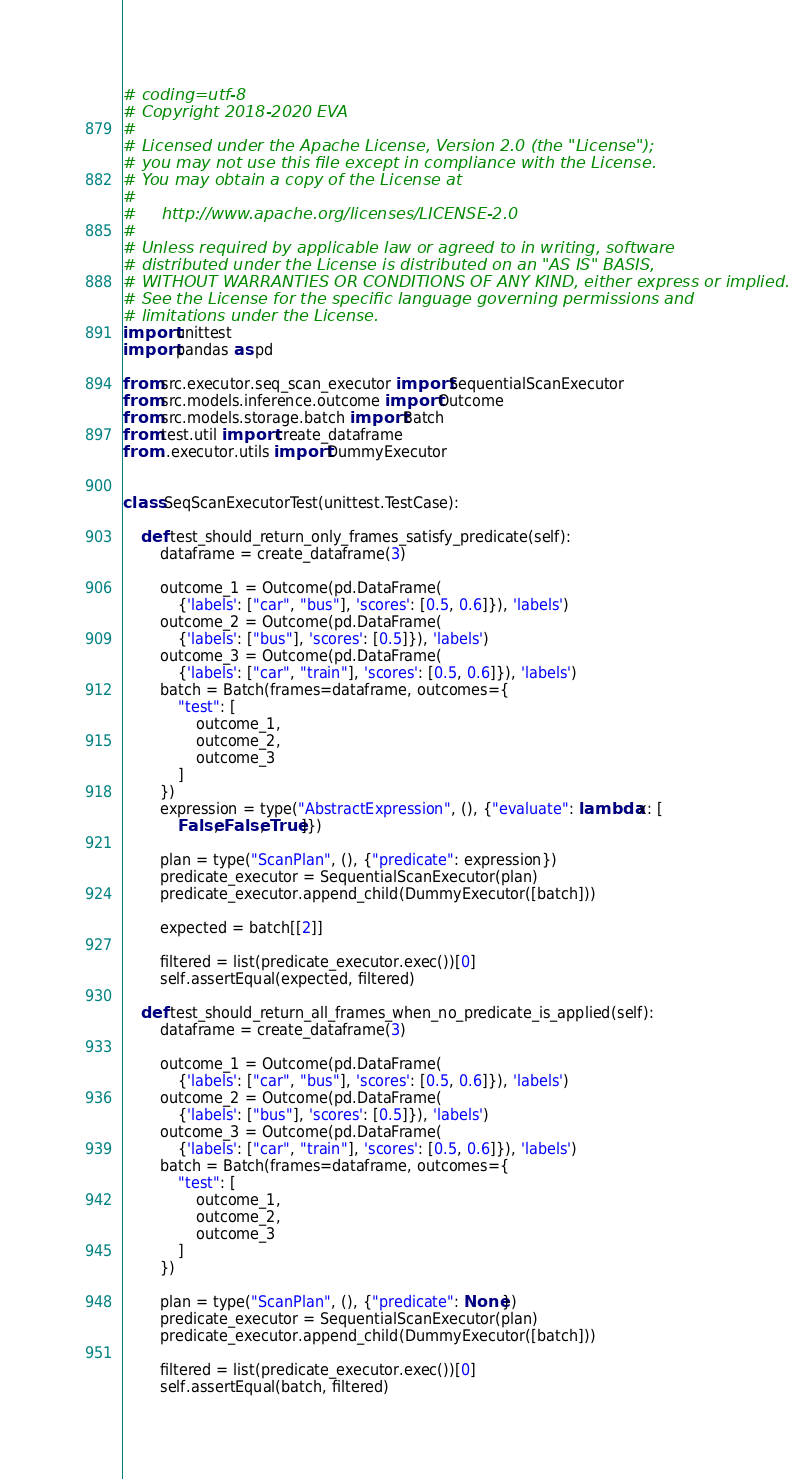Convert code to text. <code><loc_0><loc_0><loc_500><loc_500><_Python_># coding=utf-8
# Copyright 2018-2020 EVA
#
# Licensed under the Apache License, Version 2.0 (the "License");
# you may not use this file except in compliance with the License.
# You may obtain a copy of the License at
#
#     http://www.apache.org/licenses/LICENSE-2.0
#
# Unless required by applicable law or agreed to in writing, software
# distributed under the License is distributed on an "AS IS" BASIS,
# WITHOUT WARRANTIES OR CONDITIONS OF ANY KIND, either express or implied.
# See the License for the specific language governing permissions and
# limitations under the License.
import unittest
import pandas as pd

from src.executor.seq_scan_executor import SequentialScanExecutor
from src.models.inference.outcome import Outcome
from src.models.storage.batch import Batch
from test.util import create_dataframe
from ..executor.utils import DummyExecutor


class SeqScanExecutorTest(unittest.TestCase):

    def test_should_return_only_frames_satisfy_predicate(self):
        dataframe = create_dataframe(3)

        outcome_1 = Outcome(pd.DataFrame(
            {'labels': ["car", "bus"], 'scores': [0.5, 0.6]}), 'labels')
        outcome_2 = Outcome(pd.DataFrame(
            {'labels': ["bus"], 'scores': [0.5]}), 'labels')
        outcome_3 = Outcome(pd.DataFrame(
            {'labels': ["car", "train"], 'scores': [0.5, 0.6]}), 'labels')
        batch = Batch(frames=dataframe, outcomes={
            "test": [
                outcome_1,
                outcome_2,
                outcome_3
            ]
        })
        expression = type("AbstractExpression", (), {"evaluate": lambda x: [
            False, False, True]})

        plan = type("ScanPlan", (), {"predicate": expression})
        predicate_executor = SequentialScanExecutor(plan)
        predicate_executor.append_child(DummyExecutor([batch]))

        expected = batch[[2]]

        filtered = list(predicate_executor.exec())[0]
        self.assertEqual(expected, filtered)

    def test_should_return_all_frames_when_no_predicate_is_applied(self):
        dataframe = create_dataframe(3)

        outcome_1 = Outcome(pd.DataFrame(
            {'labels': ["car", "bus"], 'scores': [0.5, 0.6]}), 'labels')
        outcome_2 = Outcome(pd.DataFrame(
            {'labels': ["bus"], 'scores': [0.5]}), 'labels')
        outcome_3 = Outcome(pd.DataFrame(
            {'labels': ["car", "train"], 'scores': [0.5, 0.6]}), 'labels')
        batch = Batch(frames=dataframe, outcomes={
            "test": [
                outcome_1,
                outcome_2,
                outcome_3
            ]
        })

        plan = type("ScanPlan", (), {"predicate": None})
        predicate_executor = SequentialScanExecutor(plan)
        predicate_executor.append_child(DummyExecutor([batch]))

        filtered = list(predicate_executor.exec())[0]
        self.assertEqual(batch, filtered)
</code> 